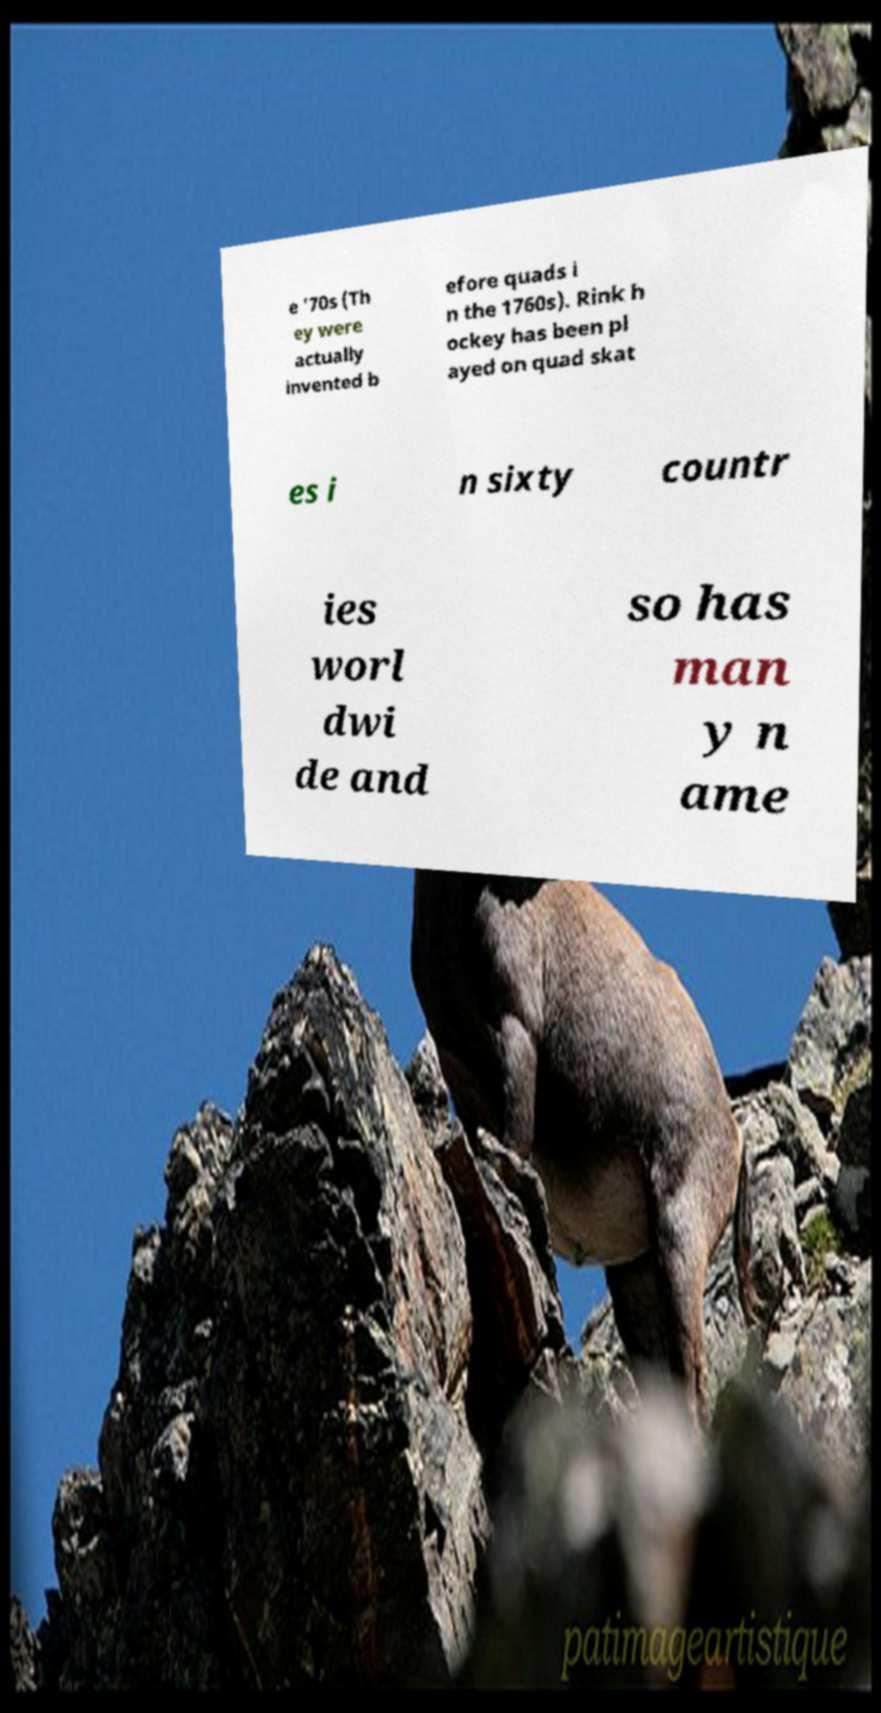Can you accurately transcribe the text from the provided image for me? e '70s (Th ey were actually invented b efore quads i n the 1760s). Rink h ockey has been pl ayed on quad skat es i n sixty countr ies worl dwi de and so has man y n ame 